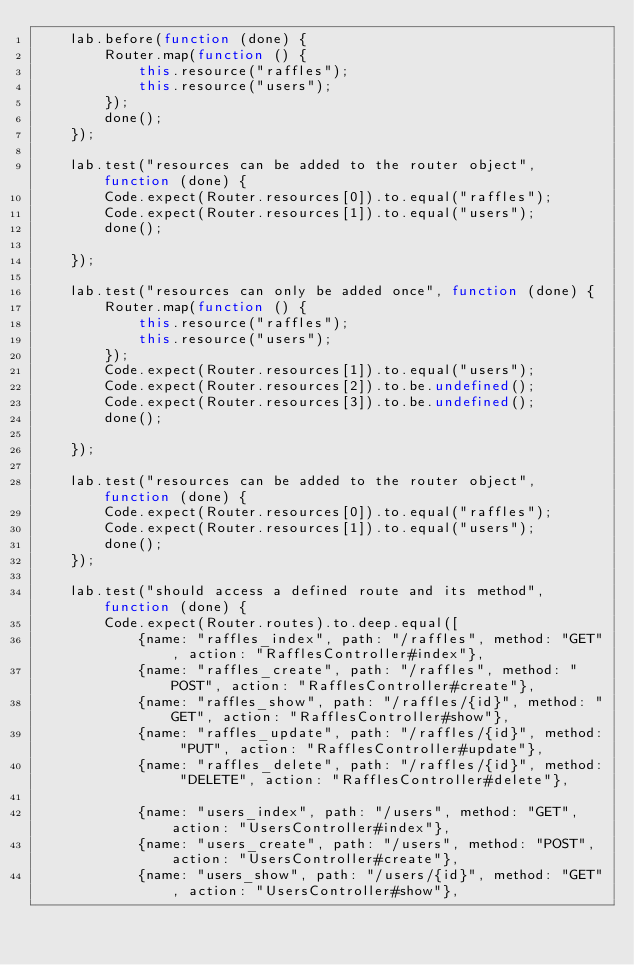<code> <loc_0><loc_0><loc_500><loc_500><_JavaScript_>    lab.before(function (done) {
        Router.map(function () {
            this.resource("raffles");
            this.resource("users");
        });
        done();
    });

    lab.test("resources can be added to the router object", function (done) {
        Code.expect(Router.resources[0]).to.equal("raffles");
        Code.expect(Router.resources[1]).to.equal("users");
        done();

    });

    lab.test("resources can only be added once", function (done) {
        Router.map(function () {
            this.resource("raffles");
            this.resource("users");
        });
        Code.expect(Router.resources[1]).to.equal("users");
        Code.expect(Router.resources[2]).to.be.undefined();
        Code.expect(Router.resources[3]).to.be.undefined();
        done();

    });

    lab.test("resources can be added to the router object", function (done) {
        Code.expect(Router.resources[0]).to.equal("raffles");
        Code.expect(Router.resources[1]).to.equal("users");
        done();
    });

    lab.test("should access a defined route and its method", function (done) {
        Code.expect(Router.routes).to.deep.equal([
            {name: "raffles_index", path: "/raffles", method: "GET", action: "RafflesController#index"},
            {name: "raffles_create", path: "/raffles", method: "POST", action: "RafflesController#create"},
            {name: "raffles_show", path: "/raffles/{id}", method: "GET", action: "RafflesController#show"},
            {name: "raffles_update", path: "/raffles/{id}", method: "PUT", action: "RafflesController#update"},
            {name: "raffles_delete", path: "/raffles/{id}", method: "DELETE", action: "RafflesController#delete"},

            {name: "users_index", path: "/users", method: "GET", action: "UsersController#index"},
            {name: "users_create", path: "/users", method: "POST", action: "UsersController#create"},
            {name: "users_show", path: "/users/{id}", method: "GET", action: "UsersController#show"},</code> 